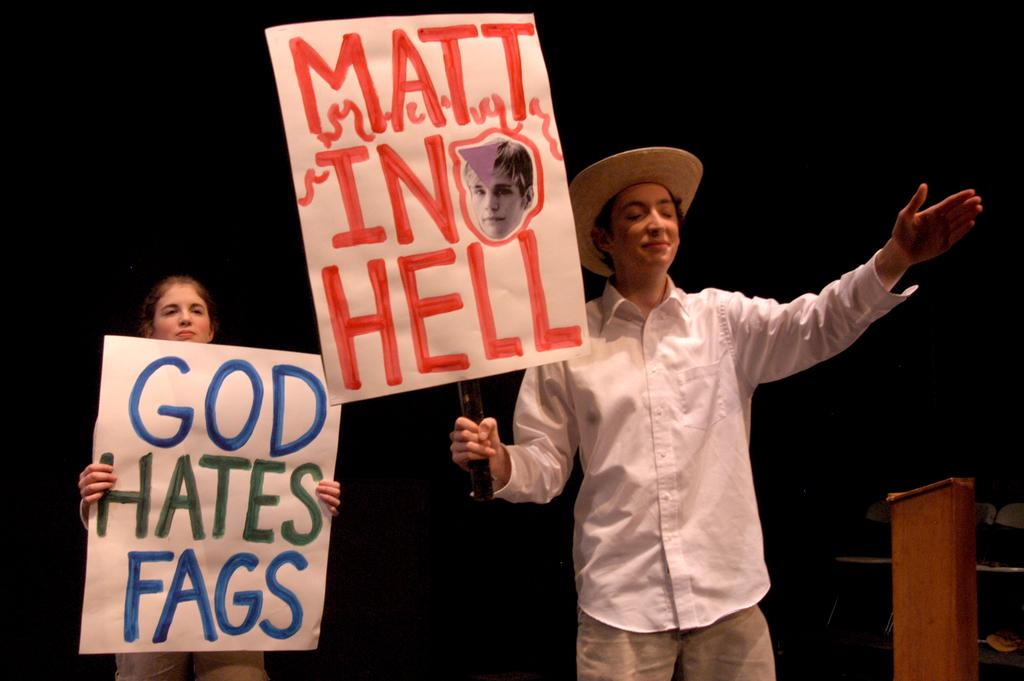How many people are in the image? There are two people in the image, a man and a woman. What are the man and woman holding in the image? The man and woman are holding banners in the image. What position are the man and woman in? The man and woman are standing in the image. What can be observed about the background of the image? The background of the image is dark. What type of clam is being used as a prop in the image? There is no clam present in the image. How many sticks are being held by the man and woman in the image? The man and woman are not holding any sticks in the image; they are holding banners. 